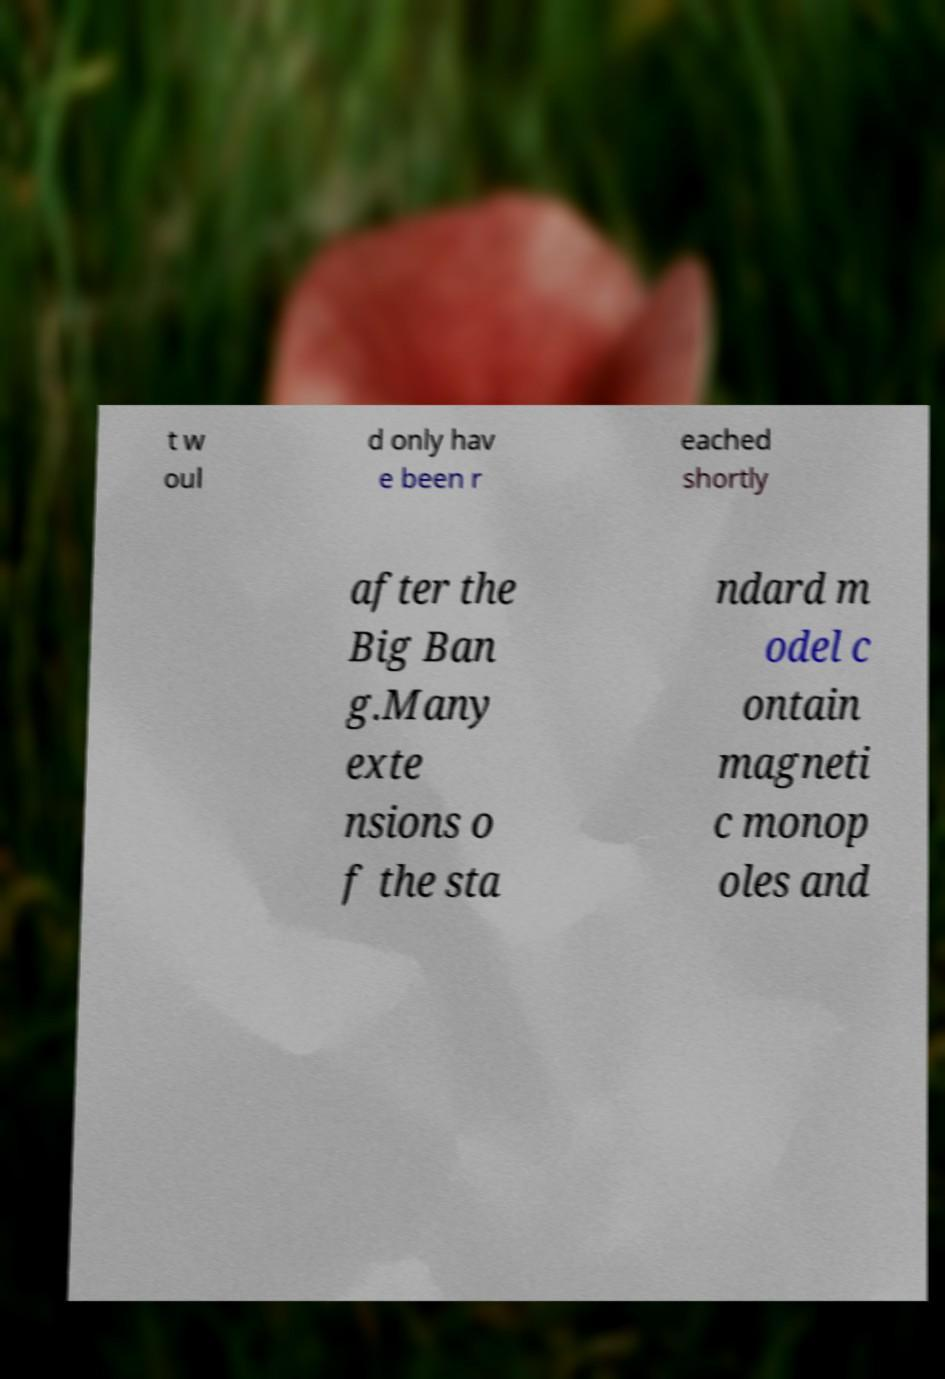What messages or text are displayed in this image? I need them in a readable, typed format. t w oul d only hav e been r eached shortly after the Big Ban g.Many exte nsions o f the sta ndard m odel c ontain magneti c monop oles and 